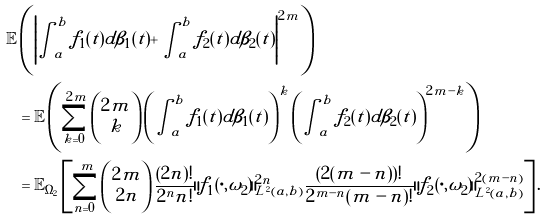<formula> <loc_0><loc_0><loc_500><loc_500>\mathbb { E } & \left ( \left | \int _ { a } ^ { b } f _ { 1 } ( t ) d \beta _ { 1 } ( t ) + \int _ { a } ^ { b } f _ { 2 } ( t ) d \beta _ { 2 } ( t ) \right | ^ { 2 m } \right ) \\ & = \mathbb { E } \left ( \sum _ { k = 0 } ^ { 2 m } \begin{pmatrix} 2 m \\ k \end{pmatrix} \left ( \int _ { a } ^ { b } f _ { 1 } ( t ) d \beta _ { 1 } ( t ) \right ) ^ { k } \left ( \int _ { a } ^ { b } f _ { 2 } ( t ) d \beta _ { 2 } ( t ) \right ) ^ { 2 m - k } \right ) \\ & = \mathbb { E } _ { \Omega _ { 2 } } \left [ \sum _ { n = 0 } ^ { m } \begin{pmatrix} 2 m \\ 2 n \end{pmatrix} \frac { ( 2 n ) ! } { 2 ^ { n } n ! } \| f _ { 1 } ( \cdot , \omega _ { 2 } ) \| _ { L ^ { 2 } ( a , b ) } ^ { 2 n } \frac { ( 2 ( m - n ) ) ! } { 2 ^ { m - n } ( m - n ) ! } \| f _ { 2 } ( \cdot , \omega _ { 2 } ) \| _ { L ^ { 2 } ( a , b ) } ^ { 2 ( m - n ) } \right ] .</formula> 